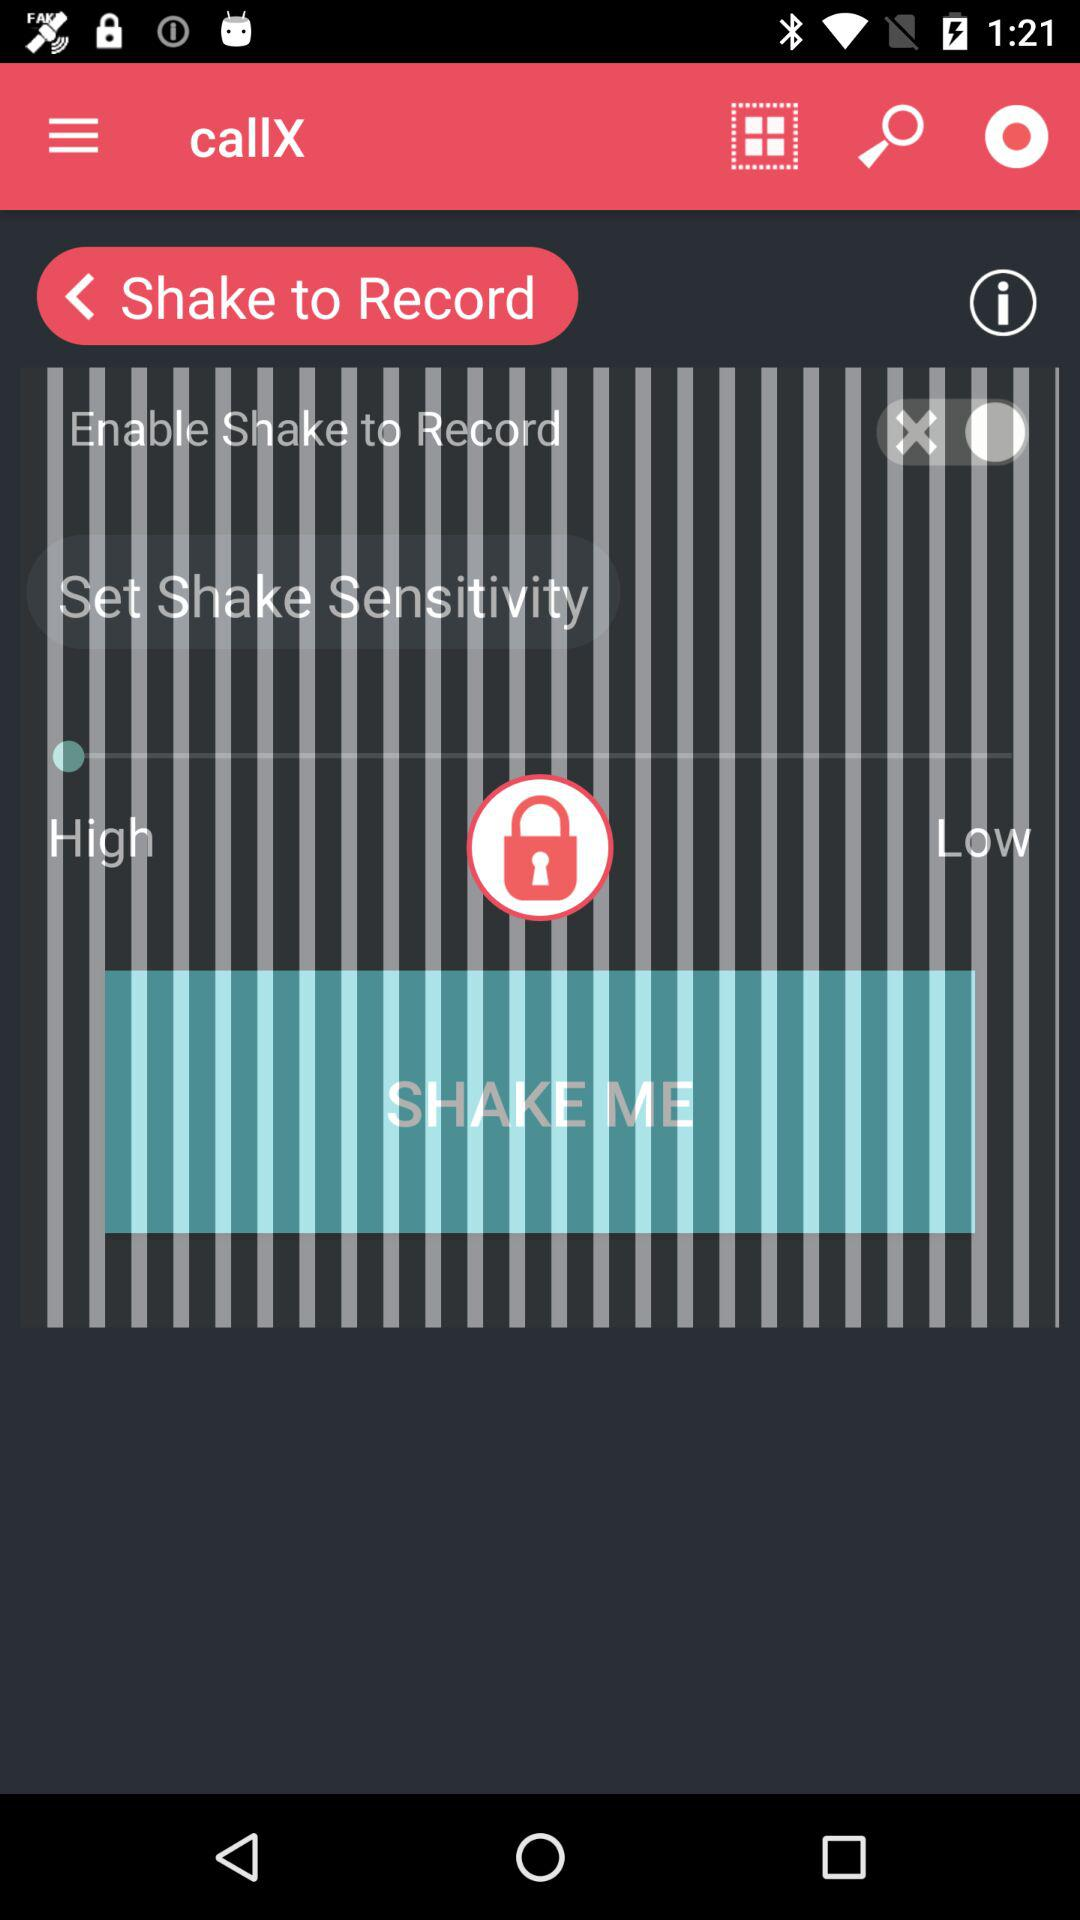How many more options are there for shake sensitivity than for launch apps?
Answer the question using a single word or phrase. 2 